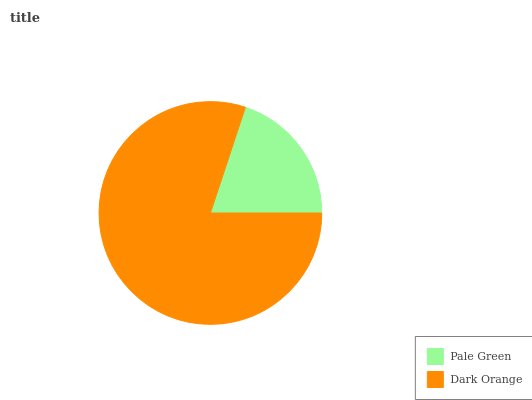Is Pale Green the minimum?
Answer yes or no. Yes. Is Dark Orange the maximum?
Answer yes or no. Yes. Is Dark Orange the minimum?
Answer yes or no. No. Is Dark Orange greater than Pale Green?
Answer yes or no. Yes. Is Pale Green less than Dark Orange?
Answer yes or no. Yes. Is Pale Green greater than Dark Orange?
Answer yes or no. No. Is Dark Orange less than Pale Green?
Answer yes or no. No. Is Dark Orange the high median?
Answer yes or no. Yes. Is Pale Green the low median?
Answer yes or no. Yes. Is Pale Green the high median?
Answer yes or no. No. Is Dark Orange the low median?
Answer yes or no. No. 